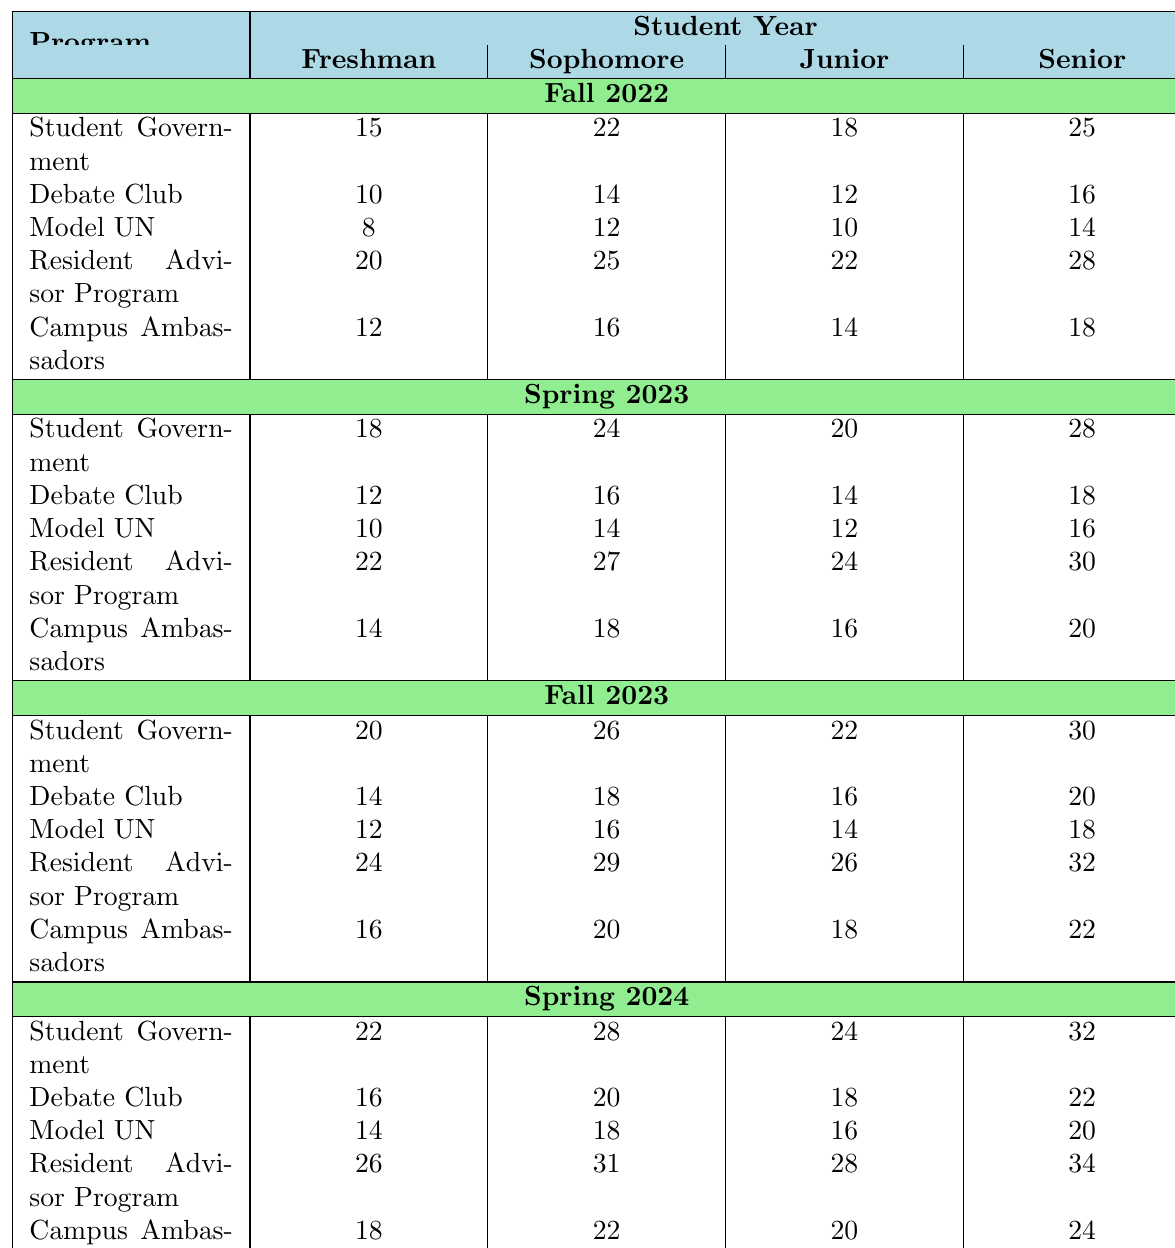What is the participation rate for Freshmen in the Student Government program during Fall 2022? According to the table, the participation rate for Freshmen in the Student Government program during Fall 2022 is directly listed as 15.
Answer: 15 What is the maximum participation rate for any group in the Debate Club across all semesters? The participation rates for the Debate Club are 10, 12, 14, and 16 for Freshmen, Sophomores, Juniors, and Seniors respectively in Fall 2022; 12, 16, 14, and 18 in Spring 2023; 14, 18, 16, and 20 in Fall 2023; and 16, 20, 18, and 22 in Spring 2024. The maximum rate of these values is 22.
Answer: 22 Is the participation rate for Seniors in the Model UN program lower in Spring 2023 than in Fall 2023? In Spring 2023, the participation rate for Seniors in the Model UN program is 16, while in Fall 2023, it is 18. Since 16 is less than 18, the participation rate in Spring 2023 is indeed lower.
Answer: Yes What is the average participation rate of Sophomores in the Resident Advisor Program across all semesters? The participation rates for Sophomores in the Resident Advisor Program are 25 (Fall 2022), 27 (Spring 2023), 29 (Fall 2023), and 31 (Spring 2024). The average is calculated as (25 + 27 + 29 + 31) / 4 = 28.
Answer: 28 Which program shows the highest participation rate for Juniors in Spring 2024? The participation rates for Juniors in Spring 2024 are 24 (Student Government), 18 (Debate Club), 16 (Model UN), 28 (Resident Advisor Program), and 20 (Campus Ambassadors). The highest is from the Resident Advisor Program with a rate of 28.
Answer: 28 What is the increase in participation rate for Freshmen in Campus Ambassadors from Fall 2022 to Spring 2024? The participation rate for Freshmen in Campus Ambassadors is 12 (Fall 2022) and 18 (Spring 2024). The increase is calculated as 18 - 12 = 6.
Answer: 6 What trend in participation rates can be observed for Seniors in the Student Government program from Fall 2022 to Spring 2024? The participation rates for Seniors in the Student Government are 25 (Fall 2022), 28 (Spring 2023), 30 (Fall 2023), and 32 (Spring 2024). The trend shows a consistent increase in participation rates over the semesters.
Answer: Increasing Is the participation rate for Sophomores in the Model UN program the same in Fall 2023 and Spring 2024? The participation rate for Sophomores in the Model UN program in Fall 2023 is 16, while in Spring 2024 it is 18, thus they are not the same.
Answer: No What is the difference between the highest and lowest participation rates for Juniors in the Debate Club across all semesters? The participation rates for Juniors in the Debate Club are 12 (Fall 2022), 14 (Spring 2023), 16 (Fall 2023), and 18 (Spring 2024). The highest is 18 and the lowest is 12. The difference is 18 - 12 = 6.
Answer: 6 How many programs have a participation rate of 20 or more for Seniors in Spring 2023? Looking at the rates for Seniors in Spring 2023, we have Student Government (28), Debate Club (18), Model UN (16), Resident Advisor Program (30), and Campus Ambassadors (20). The programs with 20 or more are Student Government, Resident Advisor Program, and Campus Ambassadors, totaling three programs.
Answer: 3 